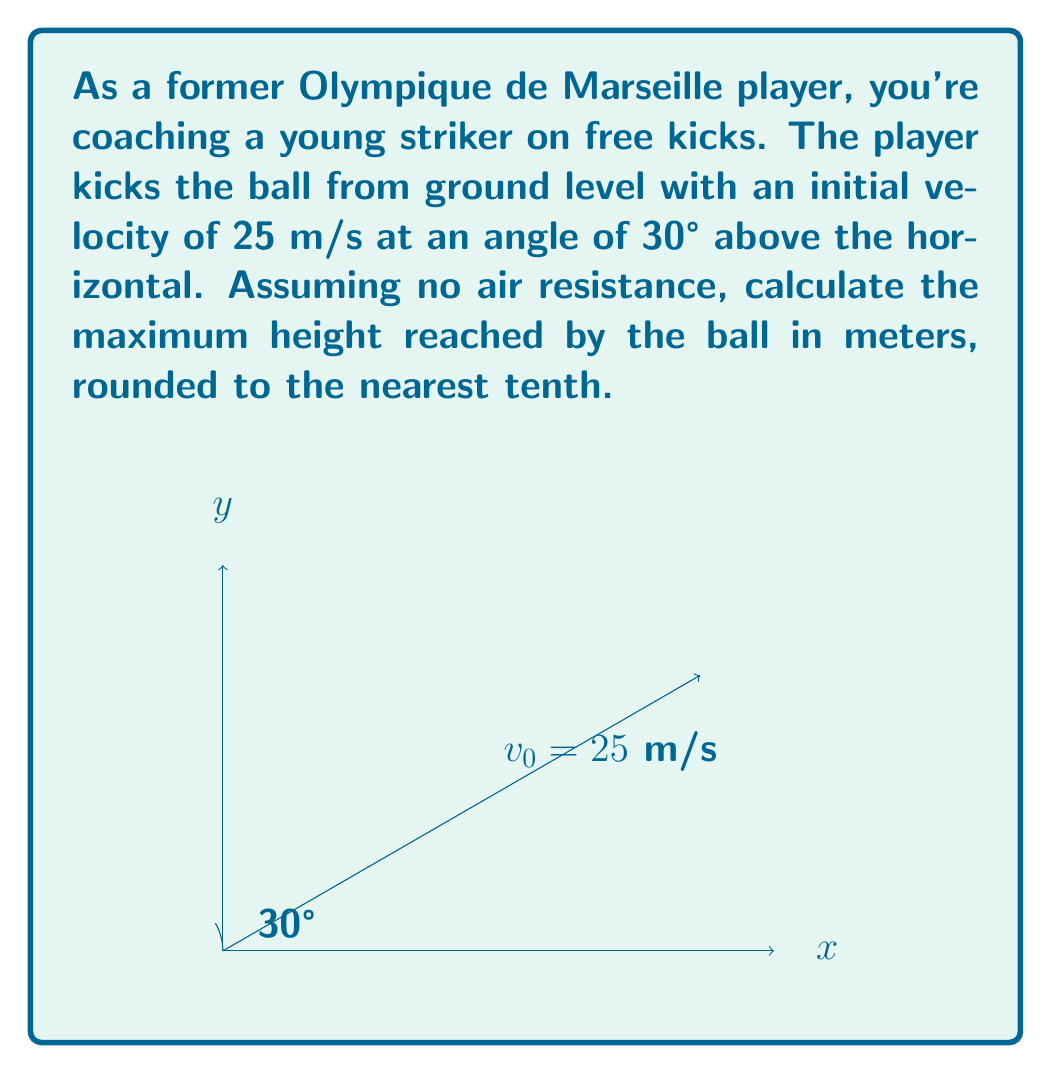What is the answer to this math problem? Let's approach this step-by-step:

1) The maximum height is determined by the vertical component of the velocity. We need to find the initial vertical velocity (v₀y).

2) Given:
   - Initial velocity (v₀) = 25 m/s
   - Angle (θ) = 30°

3) The initial vertical velocity is:
   $$v_{0y} = v_0 \sin(\theta) = 25 \sin(30°) = 25 \cdot 0.5 = 12.5 \text{ m/s}$$

4) To find the maximum height, we use the equation:
   $$h_{max} = \frac{v_{0y}^2}{2g}$$
   where g is the acceleration due to gravity (9.8 m/s²)

5) Substituting our values:
   $$h_{max} = \frac{(12.5 \text{ m/s})^2}{2(9.8 \text{ m/s}^2)} = \frac{156.25}{19.6} = 7.97 \text{ m}$$

6) Rounding to the nearest tenth:
   $$h_{max} \approx 8.0 \text{ m}$$
Answer: 8.0 m 